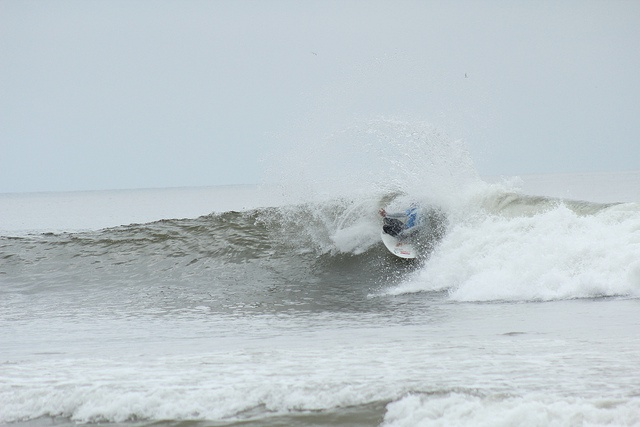Describe the objects in this image and their specific colors. I can see people in lightgray, gray, darkgray, and black tones and surfboard in lightgray, darkgray, and gray tones in this image. 